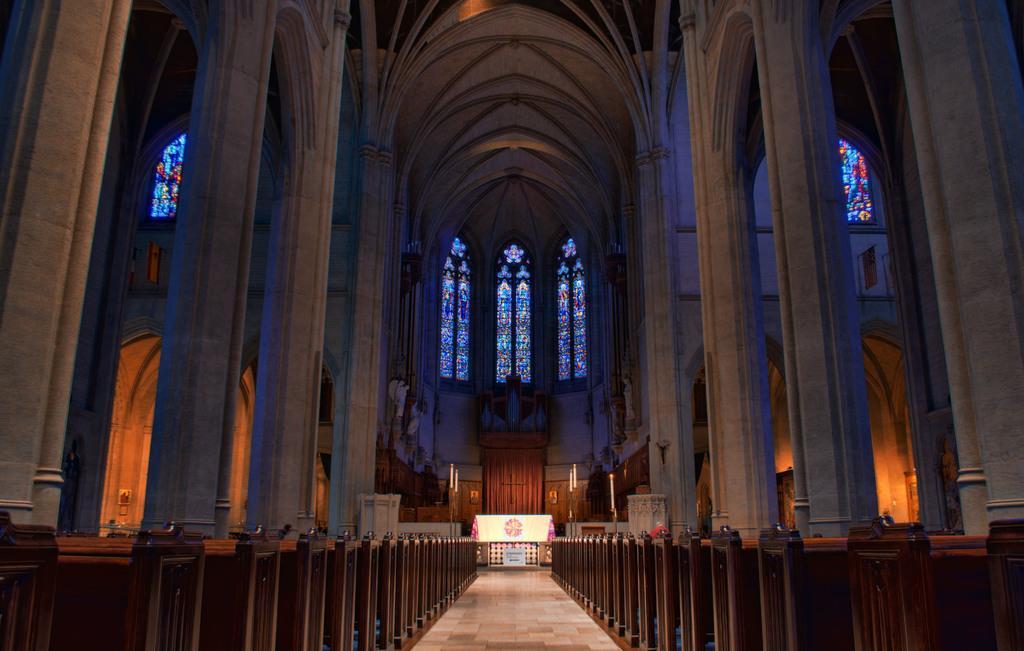Could you give a brief overview of what you see in this image? In this image I can see inside view of a church and on the both sides of this image I can see brown colour benches. On the top side of the image I can see few glass windows and in the background I can see few white colour things. 